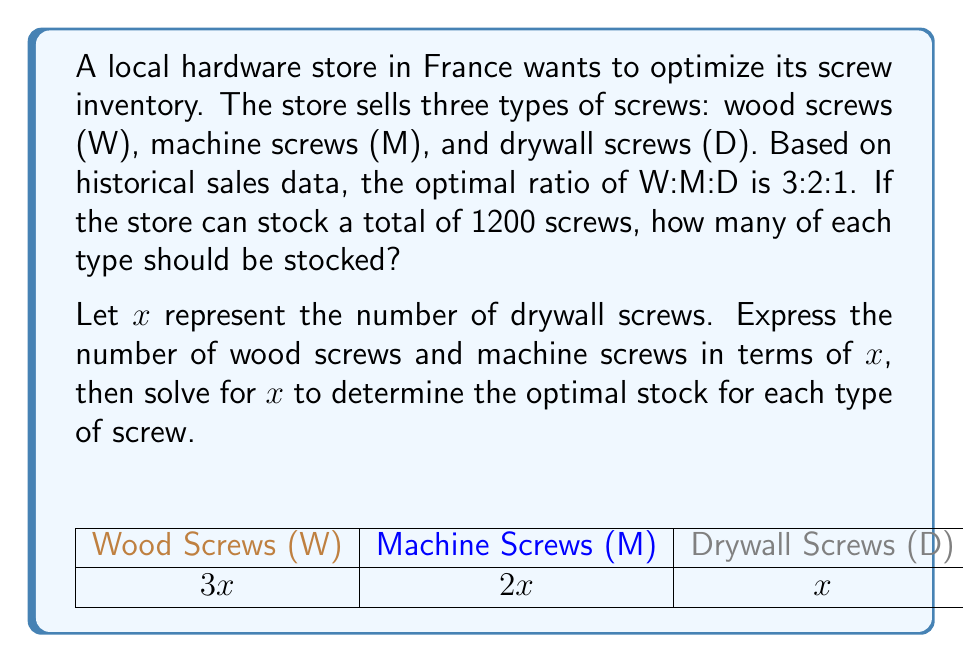Teach me how to tackle this problem. Let's approach this step-by-step:

1) Given the ratio W:M:D = 3:2:1, we can express each type in terms of $x$ (drywall screws):
   Drywall screws (D) = $x$
   Machine screws (M) = $2x$
   Wood screws (W) = $3x$

2) The total number of screws is 1200, so we can set up the equation:
   $$x + 2x + 3x = 1200$$

3) Simplify the left side of the equation:
   $$6x = 1200$$

4) Solve for $x$:
   $$x = 1200 \div 6 = 200$$

5) Now that we know $x$, we can calculate the number of each type of screw:
   Drywall screws (D) = $x = 200$
   Machine screws (M) = $2x = 2(200) = 400$
   Wood screws (W) = $3x = 3(200) = 600$

6) Verify: $200 + 400 + 600 = 1200$, which matches the total stock capacity.
Answer: Wood screws: 600, Machine screws: 400, Drywall screws: 200 